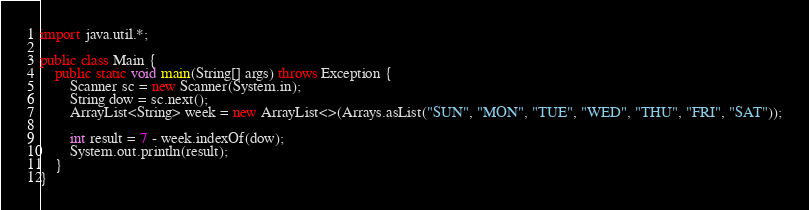<code> <loc_0><loc_0><loc_500><loc_500><_Java_>import java.util.*;

public class Main {
    public static void main(String[] args) throws Exception {
        Scanner sc = new Scanner(System.in);
        String dow = sc.next();
        ArrayList<String> week = new ArrayList<>(Arrays.asList("SUN", "MON", "TUE", "WED", "THU", "FRI", "SAT"));
        
        int result = 7 - week.indexOf(dow); 
        System.out.println(result);
    }
}
</code> 